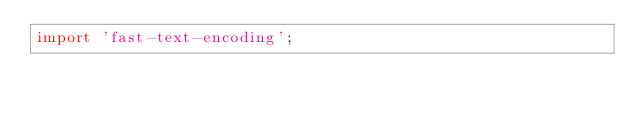<code> <loc_0><loc_0><loc_500><loc_500><_JavaScript_>import 'fast-text-encoding';
</code> 